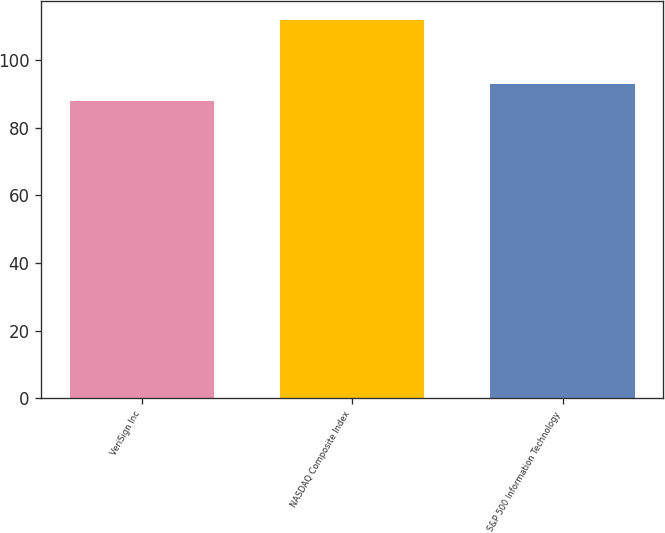Convert chart to OTSL. <chart><loc_0><loc_0><loc_500><loc_500><bar_chart><fcel>VeriSign Inc<fcel>NASDAQ Composite Index<fcel>S&P 500 Information Technology<nl><fcel>88<fcel>112<fcel>93<nl></chart> 